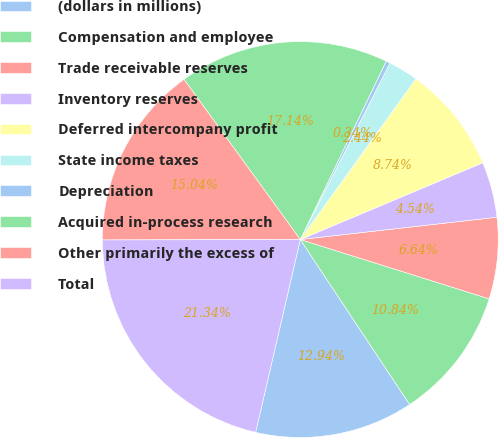Convert chart. <chart><loc_0><loc_0><loc_500><loc_500><pie_chart><fcel>(dollars in millions)<fcel>Compensation and employee<fcel>Trade receivable reserves<fcel>Inventory reserves<fcel>Deferred intercompany profit<fcel>State income taxes<fcel>Depreciation<fcel>Acquired in-process research<fcel>Other primarily the excess of<fcel>Total<nl><fcel>12.94%<fcel>10.84%<fcel>6.64%<fcel>4.54%<fcel>8.74%<fcel>2.44%<fcel>0.34%<fcel>17.14%<fcel>15.04%<fcel>21.34%<nl></chart> 